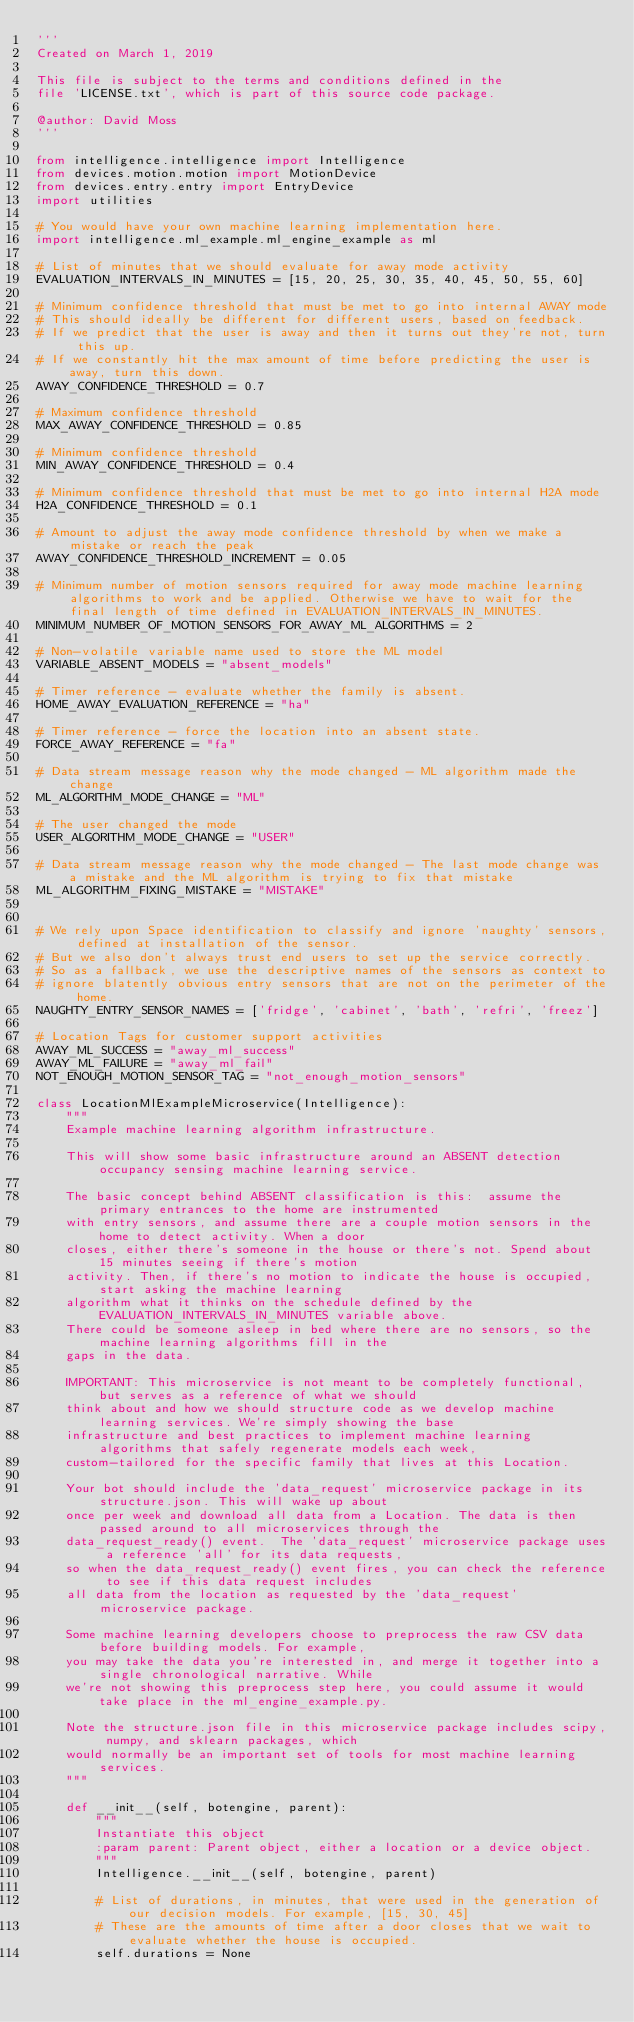<code> <loc_0><loc_0><loc_500><loc_500><_Python_>'''
Created on March 1, 2019

This file is subject to the terms and conditions defined in the
file 'LICENSE.txt', which is part of this source code package.

@author: David Moss
'''

from intelligence.intelligence import Intelligence
from devices.motion.motion import MotionDevice
from devices.entry.entry import EntryDevice
import utilities

# You would have your own machine learning implementation here.
import intelligence.ml_example.ml_engine_example as ml

# List of minutes that we should evaluate for away mode activity
EVALUATION_INTERVALS_IN_MINUTES = [15, 20, 25, 30, 35, 40, 45, 50, 55, 60]

# Minimum confidence threshold that must be met to go into internal AWAY mode
# This should ideally be different for different users, based on feedback.
# If we predict that the user is away and then it turns out they're not, turn this up.
# If we constantly hit the max amount of time before predicting the user is away, turn this down.
AWAY_CONFIDENCE_THRESHOLD = 0.7

# Maximum confidence threshold
MAX_AWAY_CONFIDENCE_THRESHOLD = 0.85

# Minimum confidence threshold
MIN_AWAY_CONFIDENCE_THRESHOLD = 0.4

# Minimum confidence threshold that must be met to go into internal H2A mode
H2A_CONFIDENCE_THRESHOLD = 0.1

# Amount to adjust the away mode confidence threshold by when we make a mistake or reach the peak
AWAY_CONFIDENCE_THRESHOLD_INCREMENT = 0.05

# Minimum number of motion sensors required for away mode machine learning algorithms to work and be applied. Otherwise we have to wait for the final length of time defined in EVALUATION_INTERVALS_IN_MINUTES.
MINIMUM_NUMBER_OF_MOTION_SENSORS_FOR_AWAY_ML_ALGORITHMS = 2

# Non-volatile variable name used to store the ML model
VARIABLE_ABSENT_MODELS = "absent_models"

# Timer reference - evaluate whether the family is absent.
HOME_AWAY_EVALUATION_REFERENCE = "ha"

# Timer reference - force the location into an absent state.
FORCE_AWAY_REFERENCE = "fa"

# Data stream message reason why the mode changed - ML algorithm made the change
ML_ALGORITHM_MODE_CHANGE = "ML"

# The user changed the mode
USER_ALGORITHM_MODE_CHANGE = "USER"

# Data stream message reason why the mode changed - The last mode change was a mistake and the ML algorithm is trying to fix that mistake
ML_ALGORITHM_FIXING_MISTAKE = "MISTAKE"


# We rely upon Space identification to classify and ignore 'naughty' sensors, defined at installation of the sensor.
# But we also don't always trust end users to set up the service correctly.
# So as a fallback, we use the descriptive names of the sensors as context to
# ignore blatently obvious entry sensors that are not on the perimeter of the home.
NAUGHTY_ENTRY_SENSOR_NAMES = ['fridge', 'cabinet', 'bath', 'refri', 'freez']

# Location Tags for customer support activities
AWAY_ML_SUCCESS = "away_ml_success"
AWAY_ML_FAILURE = "away_ml_fail"
NOT_ENOUGH_MOTION_SENSOR_TAG = "not_enough_motion_sensors"

class LocationMlExampleMicroservice(Intelligence):
    """
    Example machine learning algorithm infrastructure.

    This will show some basic infrastructure around an ABSENT detection occupancy sensing machine learning service.

    The basic concept behind ABSENT classification is this:  assume the primary entrances to the home are instrumented
    with entry sensors, and assume there are a couple motion sensors in the home to detect activity. When a door
    closes, either there's someone in the house or there's not. Spend about 15 minutes seeing if there's motion
    activity. Then, if there's no motion to indicate the house is occupied, start asking the machine learning
    algorithm what it thinks on the schedule defined by the EVALUATION_INTERVALS_IN_MINUTES variable above.
    There could be someone asleep in bed where there are no sensors, so the machine learning algorithms fill in the
    gaps in the data.

    IMPORTANT: This microservice is not meant to be completely functional, but serves as a reference of what we should
    think about and how we should structure code as we develop machine learning services. We're simply showing the base
    infrastructure and best practices to implement machine learning algorithms that safely regenerate models each week,
    custom-tailored for the specific family that lives at this Location.

    Your bot should include the 'data_request' microservice package in its structure.json. This will wake up about
    once per week and download all data from a Location. The data is then passed around to all microservices through the
    data_request_ready() event.  The 'data_request' microservice package uses a reference 'all' for its data requests,
    so when the data_request_ready() event fires, you can check the reference to see if this data request includes
    all data from the location as requested by the 'data_request' microservice package.

    Some machine learning developers choose to preprocess the raw CSV data before building models. For example,
    you may take the data you're interested in, and merge it together into a single chronological narrative. While
    we're not showing this preprocess step here, you could assume it would take place in the ml_engine_example.py.

    Note the structure.json file in this microservice package includes scipy, numpy, and sklearn packages, which
    would normally be an important set of tools for most machine learning services.
    """

    def __init__(self, botengine, parent):
        """
        Instantiate this object
        :param parent: Parent object, either a location or a device object.
        """
        Intelligence.__init__(self, botengine, parent)

        # List of durations, in minutes, that were used in the generation of our decision models. For example, [15, 30, 45]
        # These are the amounts of time after a door closes that we wait to evaluate whether the house is occupied.
        self.durations = None
</code> 